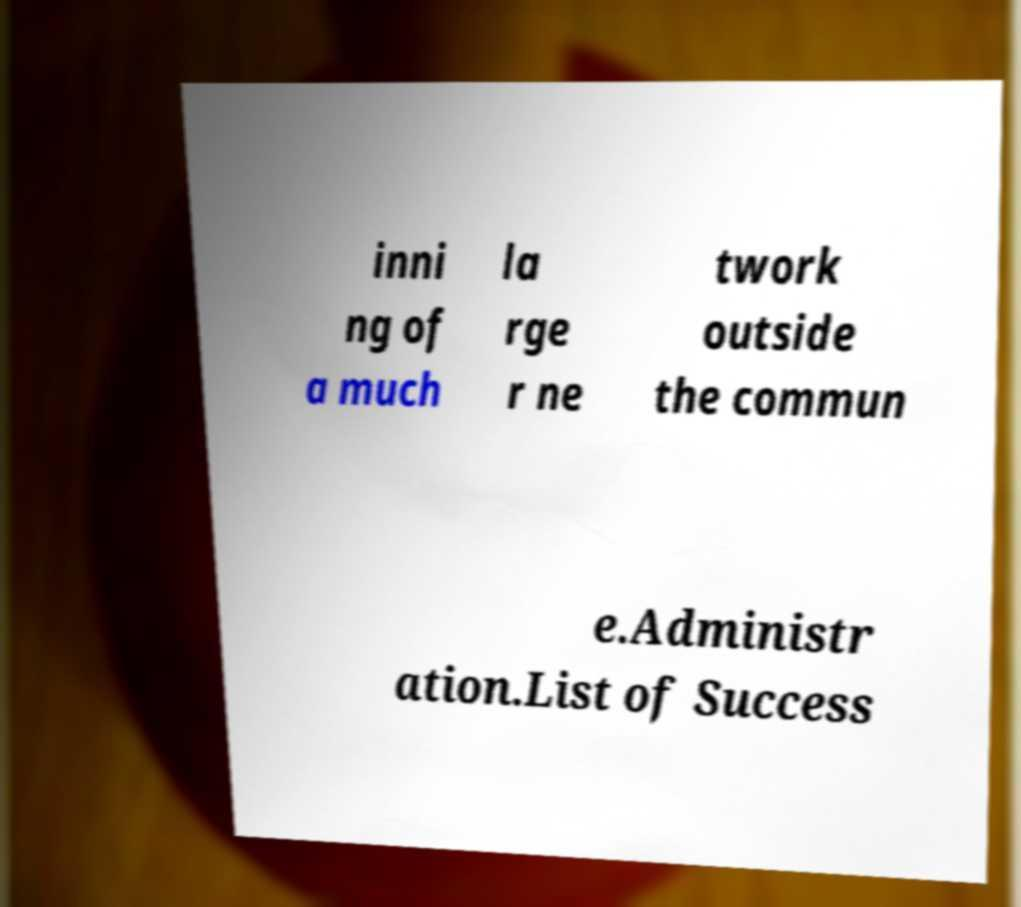Can you accurately transcribe the text from the provided image for me? inni ng of a much la rge r ne twork outside the commun e.Administr ation.List of Success 